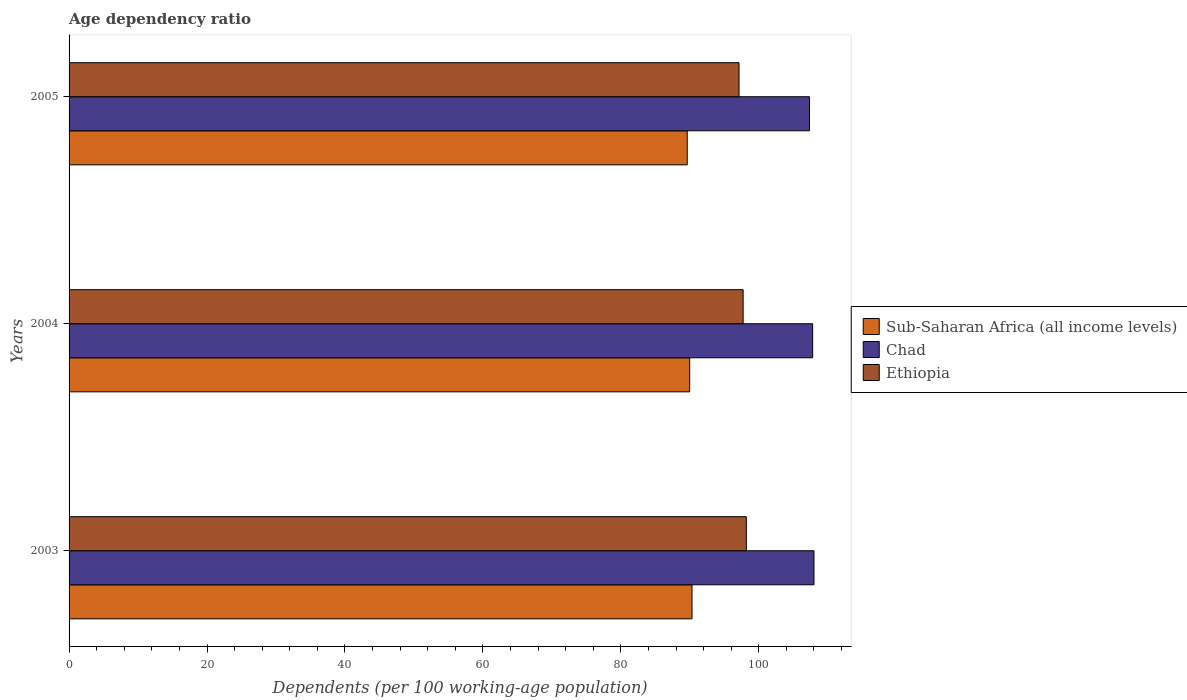How many groups of bars are there?
Provide a succinct answer. 3. Are the number of bars on each tick of the Y-axis equal?
Offer a very short reply. Yes. How many bars are there on the 1st tick from the top?
Offer a terse response. 3. How many bars are there on the 2nd tick from the bottom?
Offer a very short reply. 3. In how many cases, is the number of bars for a given year not equal to the number of legend labels?
Your answer should be compact. 0. What is the age dependency ratio in in Ethiopia in 2003?
Offer a very short reply. 98.19. Across all years, what is the maximum age dependency ratio in in Sub-Saharan Africa (all income levels)?
Your answer should be very brief. 90.32. Across all years, what is the minimum age dependency ratio in in Ethiopia?
Provide a short and direct response. 97.13. In which year was the age dependency ratio in in Sub-Saharan Africa (all income levels) maximum?
Ensure brevity in your answer.  2003. What is the total age dependency ratio in in Ethiopia in the graph?
Provide a succinct answer. 293.05. What is the difference between the age dependency ratio in in Ethiopia in 2003 and that in 2005?
Your answer should be compact. 1.06. What is the difference between the age dependency ratio in in Chad in 2004 and the age dependency ratio in in Ethiopia in 2003?
Your answer should be very brief. 9.62. What is the average age dependency ratio in in Chad per year?
Your answer should be very brief. 107.72. In the year 2005, what is the difference between the age dependency ratio in in Ethiopia and age dependency ratio in in Chad?
Provide a succinct answer. -10.22. What is the ratio of the age dependency ratio in in Ethiopia in 2004 to that in 2005?
Give a very brief answer. 1.01. Is the age dependency ratio in in Chad in 2003 less than that in 2005?
Offer a terse response. No. What is the difference between the highest and the second highest age dependency ratio in in Sub-Saharan Africa (all income levels)?
Your response must be concise. 0.33. What is the difference between the highest and the lowest age dependency ratio in in Ethiopia?
Offer a very short reply. 1.06. Is the sum of the age dependency ratio in in Chad in 2003 and 2004 greater than the maximum age dependency ratio in in Ethiopia across all years?
Provide a succinct answer. Yes. What does the 1st bar from the top in 2003 represents?
Offer a terse response. Ethiopia. What does the 1st bar from the bottom in 2003 represents?
Your response must be concise. Sub-Saharan Africa (all income levels). Is it the case that in every year, the sum of the age dependency ratio in in Chad and age dependency ratio in in Sub-Saharan Africa (all income levels) is greater than the age dependency ratio in in Ethiopia?
Offer a terse response. Yes. Does the graph contain any zero values?
Keep it short and to the point. No. How many legend labels are there?
Provide a short and direct response. 3. How are the legend labels stacked?
Provide a short and direct response. Vertical. What is the title of the graph?
Your answer should be very brief. Age dependency ratio. Does "Guam" appear as one of the legend labels in the graph?
Make the answer very short. No. What is the label or title of the X-axis?
Make the answer very short. Dependents (per 100 working-age population). What is the Dependents (per 100 working-age population) of Sub-Saharan Africa (all income levels) in 2003?
Provide a succinct answer. 90.32. What is the Dependents (per 100 working-age population) of Chad in 2003?
Make the answer very short. 108. What is the Dependents (per 100 working-age population) in Ethiopia in 2003?
Ensure brevity in your answer.  98.19. What is the Dependents (per 100 working-age population) of Sub-Saharan Africa (all income levels) in 2004?
Offer a very short reply. 89.98. What is the Dependents (per 100 working-age population) in Chad in 2004?
Your answer should be very brief. 107.81. What is the Dependents (per 100 working-age population) in Ethiopia in 2004?
Your answer should be very brief. 97.73. What is the Dependents (per 100 working-age population) in Sub-Saharan Africa (all income levels) in 2005?
Your answer should be very brief. 89.62. What is the Dependents (per 100 working-age population) of Chad in 2005?
Make the answer very short. 107.35. What is the Dependents (per 100 working-age population) of Ethiopia in 2005?
Offer a terse response. 97.13. Across all years, what is the maximum Dependents (per 100 working-age population) in Sub-Saharan Africa (all income levels)?
Make the answer very short. 90.32. Across all years, what is the maximum Dependents (per 100 working-age population) of Chad?
Provide a short and direct response. 108. Across all years, what is the maximum Dependents (per 100 working-age population) in Ethiopia?
Provide a succinct answer. 98.19. Across all years, what is the minimum Dependents (per 100 working-age population) of Sub-Saharan Africa (all income levels)?
Ensure brevity in your answer.  89.62. Across all years, what is the minimum Dependents (per 100 working-age population) in Chad?
Offer a very short reply. 107.35. Across all years, what is the minimum Dependents (per 100 working-age population) of Ethiopia?
Provide a succinct answer. 97.13. What is the total Dependents (per 100 working-age population) of Sub-Saharan Africa (all income levels) in the graph?
Provide a short and direct response. 269.92. What is the total Dependents (per 100 working-age population) in Chad in the graph?
Ensure brevity in your answer.  323.16. What is the total Dependents (per 100 working-age population) in Ethiopia in the graph?
Offer a terse response. 293.05. What is the difference between the Dependents (per 100 working-age population) of Sub-Saharan Africa (all income levels) in 2003 and that in 2004?
Your answer should be compact. 0.33. What is the difference between the Dependents (per 100 working-age population) in Chad in 2003 and that in 2004?
Your answer should be very brief. 0.19. What is the difference between the Dependents (per 100 working-age population) of Ethiopia in 2003 and that in 2004?
Your answer should be compact. 0.46. What is the difference between the Dependents (per 100 working-age population) in Sub-Saharan Africa (all income levels) in 2003 and that in 2005?
Your answer should be compact. 0.69. What is the difference between the Dependents (per 100 working-age population) in Chad in 2003 and that in 2005?
Provide a short and direct response. 0.65. What is the difference between the Dependents (per 100 working-age population) of Ethiopia in 2003 and that in 2005?
Your answer should be very brief. 1.06. What is the difference between the Dependents (per 100 working-age population) of Sub-Saharan Africa (all income levels) in 2004 and that in 2005?
Give a very brief answer. 0.36. What is the difference between the Dependents (per 100 working-age population) of Chad in 2004 and that in 2005?
Provide a succinct answer. 0.46. What is the difference between the Dependents (per 100 working-age population) of Ethiopia in 2004 and that in 2005?
Provide a succinct answer. 0.59. What is the difference between the Dependents (per 100 working-age population) of Sub-Saharan Africa (all income levels) in 2003 and the Dependents (per 100 working-age population) of Chad in 2004?
Keep it short and to the point. -17.49. What is the difference between the Dependents (per 100 working-age population) in Sub-Saharan Africa (all income levels) in 2003 and the Dependents (per 100 working-age population) in Ethiopia in 2004?
Provide a short and direct response. -7.41. What is the difference between the Dependents (per 100 working-age population) in Chad in 2003 and the Dependents (per 100 working-age population) in Ethiopia in 2004?
Make the answer very short. 10.27. What is the difference between the Dependents (per 100 working-age population) in Sub-Saharan Africa (all income levels) in 2003 and the Dependents (per 100 working-age population) in Chad in 2005?
Offer a very short reply. -17.03. What is the difference between the Dependents (per 100 working-age population) of Sub-Saharan Africa (all income levels) in 2003 and the Dependents (per 100 working-age population) of Ethiopia in 2005?
Keep it short and to the point. -6.82. What is the difference between the Dependents (per 100 working-age population) in Chad in 2003 and the Dependents (per 100 working-age population) in Ethiopia in 2005?
Offer a terse response. 10.87. What is the difference between the Dependents (per 100 working-age population) in Sub-Saharan Africa (all income levels) in 2004 and the Dependents (per 100 working-age population) in Chad in 2005?
Ensure brevity in your answer.  -17.37. What is the difference between the Dependents (per 100 working-age population) in Sub-Saharan Africa (all income levels) in 2004 and the Dependents (per 100 working-age population) in Ethiopia in 2005?
Offer a very short reply. -7.15. What is the difference between the Dependents (per 100 working-age population) of Chad in 2004 and the Dependents (per 100 working-age population) of Ethiopia in 2005?
Give a very brief answer. 10.68. What is the average Dependents (per 100 working-age population) in Sub-Saharan Africa (all income levels) per year?
Offer a terse response. 89.97. What is the average Dependents (per 100 working-age population) of Chad per year?
Provide a short and direct response. 107.72. What is the average Dependents (per 100 working-age population) in Ethiopia per year?
Provide a succinct answer. 97.68. In the year 2003, what is the difference between the Dependents (per 100 working-age population) in Sub-Saharan Africa (all income levels) and Dependents (per 100 working-age population) in Chad?
Give a very brief answer. -17.69. In the year 2003, what is the difference between the Dependents (per 100 working-age population) in Sub-Saharan Africa (all income levels) and Dependents (per 100 working-age population) in Ethiopia?
Ensure brevity in your answer.  -7.87. In the year 2003, what is the difference between the Dependents (per 100 working-age population) in Chad and Dependents (per 100 working-age population) in Ethiopia?
Offer a terse response. 9.81. In the year 2004, what is the difference between the Dependents (per 100 working-age population) of Sub-Saharan Africa (all income levels) and Dependents (per 100 working-age population) of Chad?
Your answer should be compact. -17.83. In the year 2004, what is the difference between the Dependents (per 100 working-age population) in Sub-Saharan Africa (all income levels) and Dependents (per 100 working-age population) in Ethiopia?
Your answer should be compact. -7.75. In the year 2004, what is the difference between the Dependents (per 100 working-age population) in Chad and Dependents (per 100 working-age population) in Ethiopia?
Offer a very short reply. 10.08. In the year 2005, what is the difference between the Dependents (per 100 working-age population) of Sub-Saharan Africa (all income levels) and Dependents (per 100 working-age population) of Chad?
Ensure brevity in your answer.  -17.73. In the year 2005, what is the difference between the Dependents (per 100 working-age population) of Sub-Saharan Africa (all income levels) and Dependents (per 100 working-age population) of Ethiopia?
Provide a short and direct response. -7.51. In the year 2005, what is the difference between the Dependents (per 100 working-age population) in Chad and Dependents (per 100 working-age population) in Ethiopia?
Your answer should be compact. 10.21. What is the ratio of the Dependents (per 100 working-age population) in Sub-Saharan Africa (all income levels) in 2003 to that in 2004?
Offer a very short reply. 1. What is the ratio of the Dependents (per 100 working-age population) in Ethiopia in 2003 to that in 2004?
Offer a terse response. 1. What is the ratio of the Dependents (per 100 working-age population) of Sub-Saharan Africa (all income levels) in 2003 to that in 2005?
Make the answer very short. 1.01. What is the ratio of the Dependents (per 100 working-age population) of Ethiopia in 2003 to that in 2005?
Provide a succinct answer. 1.01. What is the ratio of the Dependents (per 100 working-age population) in Sub-Saharan Africa (all income levels) in 2004 to that in 2005?
Your response must be concise. 1. What is the ratio of the Dependents (per 100 working-age population) in Chad in 2004 to that in 2005?
Your response must be concise. 1. What is the difference between the highest and the second highest Dependents (per 100 working-age population) in Sub-Saharan Africa (all income levels)?
Your answer should be compact. 0.33. What is the difference between the highest and the second highest Dependents (per 100 working-age population) of Chad?
Provide a short and direct response. 0.19. What is the difference between the highest and the second highest Dependents (per 100 working-age population) in Ethiopia?
Keep it short and to the point. 0.46. What is the difference between the highest and the lowest Dependents (per 100 working-age population) of Sub-Saharan Africa (all income levels)?
Offer a very short reply. 0.69. What is the difference between the highest and the lowest Dependents (per 100 working-age population) of Chad?
Provide a succinct answer. 0.65. What is the difference between the highest and the lowest Dependents (per 100 working-age population) of Ethiopia?
Your answer should be compact. 1.06. 